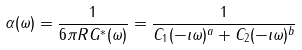<formula> <loc_0><loc_0><loc_500><loc_500>\alpha ( \omega ) = \frac { 1 } { 6 \pi R G ^ { * } ( \omega ) } = \frac { 1 } { C _ { 1 } ( - \imath \omega ) ^ { a } + C _ { 2 } ( - \imath \omega ) ^ { b } }</formula> 